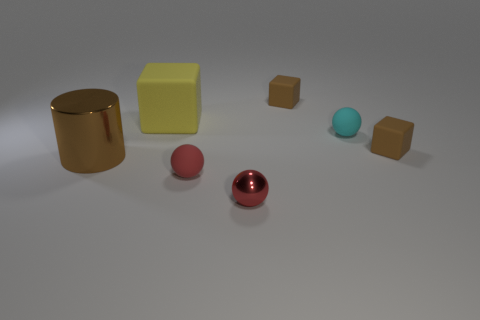Can you describe the different materials and shapes presented in the image? Certainly! The image showcases a variety of geometric shapes and materials. On the left, we see a glossy gold cylinder next to a matte yellow cube. In the center, there's a small, shiny red sphere, and behind it lies a larger red rubber sphere with a high-gloss finish. Towards the right, we observe a small turquoise sphere paired with matte brown cubes. Each of these items has a distinct texture and finish that contrasts with the others, contributing to the overall diversity of the scene. 